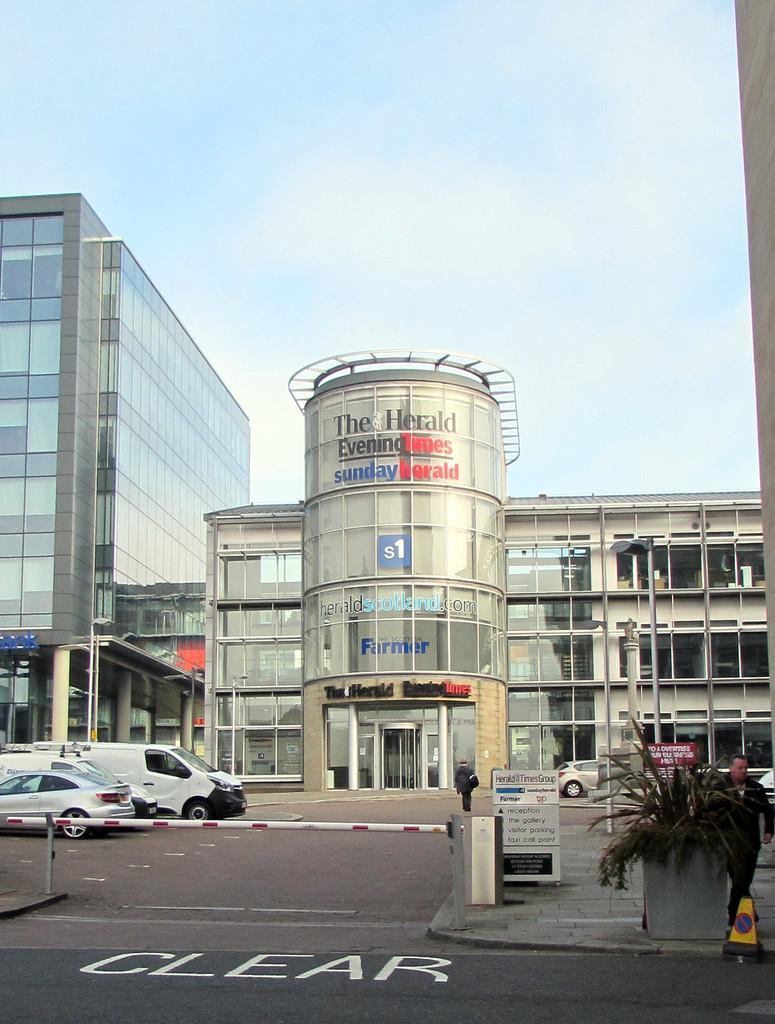Who or what can be seen in the image? There are people in the image. What else is present in the image besides people? There are cars, buildings, plants, and hoardings in the image. What type of cork can be seen in the image? There is no cork present in the image. Is there a band performing in the image? There is no band or any indication of a performance in the image. 